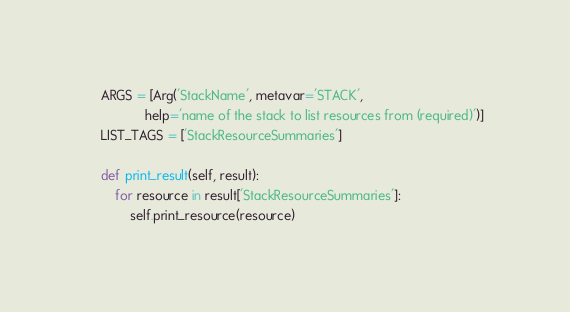Convert code to text. <code><loc_0><loc_0><loc_500><loc_500><_Python_>    ARGS = [Arg('StackName', metavar='STACK',
                help='name of the stack to list resources from (required)')]
    LIST_TAGS = ['StackResourceSummaries']

    def print_result(self, result):
        for resource in result['StackResourceSummaries']:
            self.print_resource(resource)
</code> 